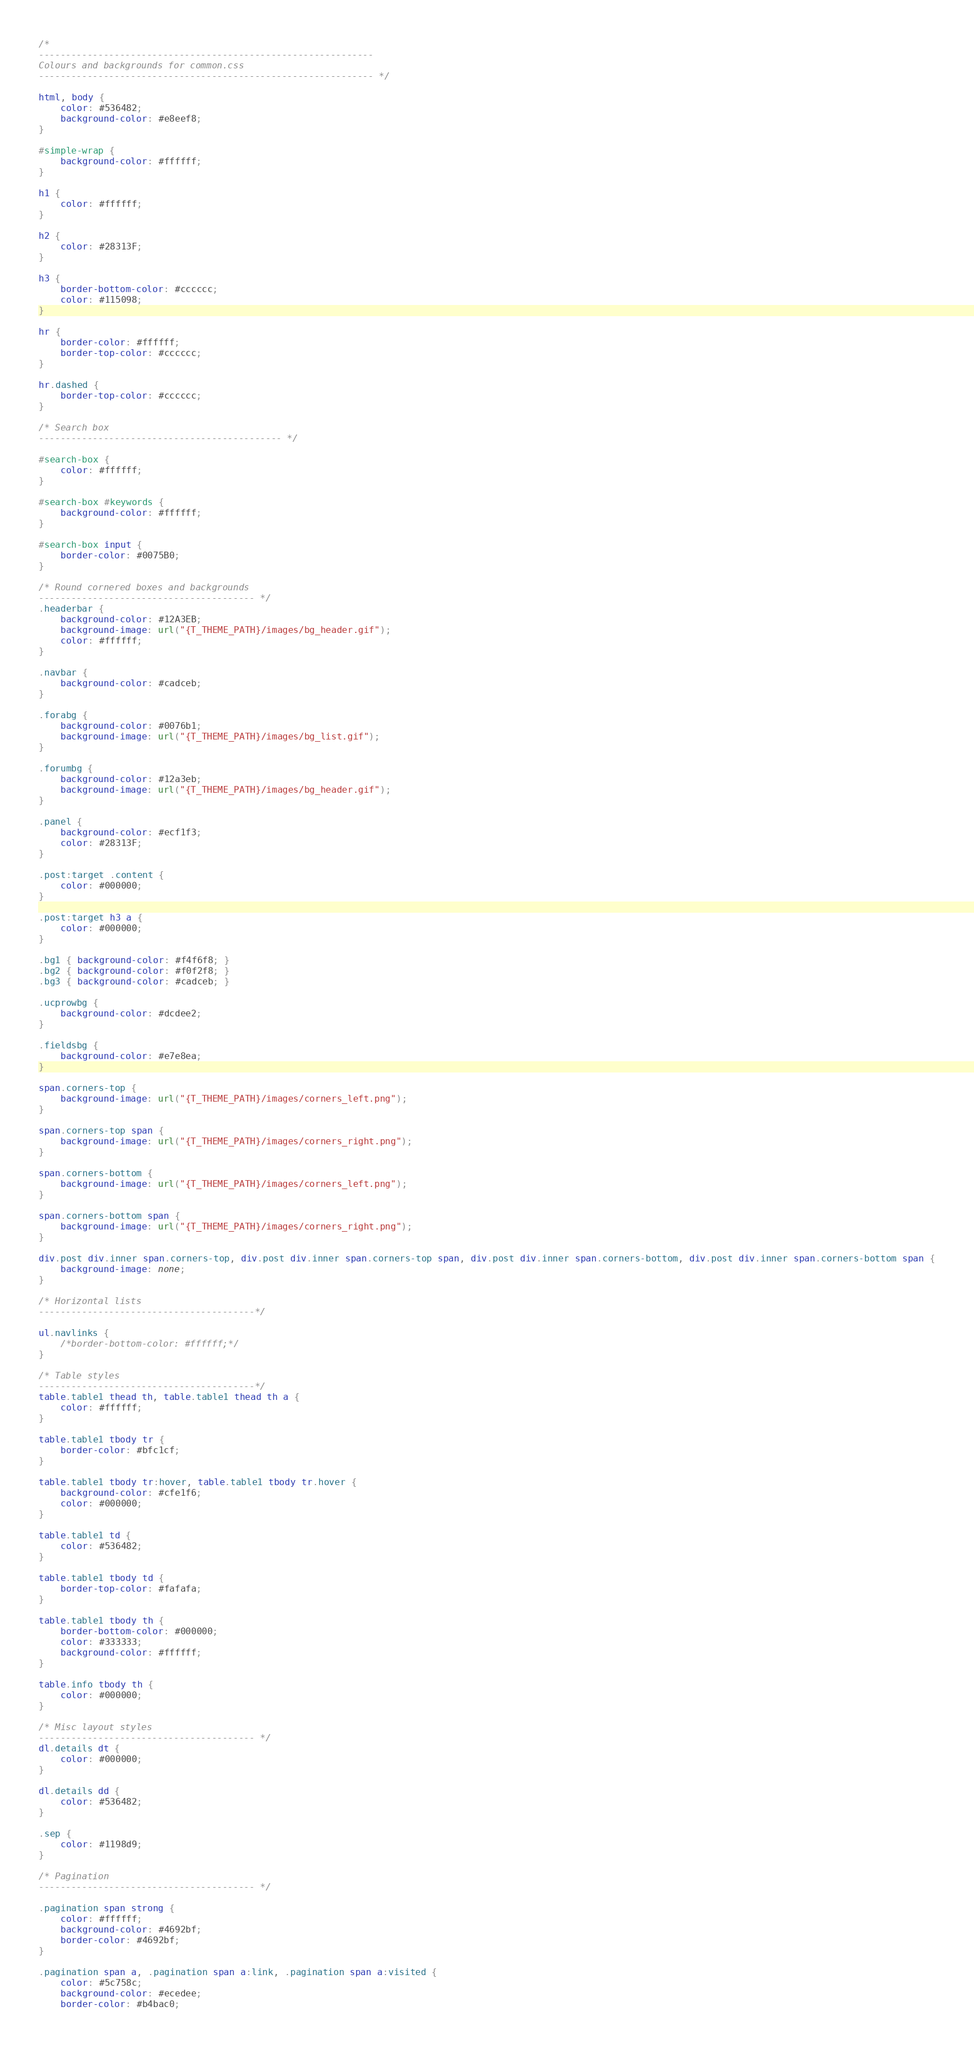<code> <loc_0><loc_0><loc_500><loc_500><_CSS_>/*
--------------------------------------------------------------
Colours and backgrounds for common.css
-------------------------------------------------------------- */

html, body {
	color: #536482;
	background-color: #e8eef8;
}

#simple-wrap {
	background-color: #ffffff;
}

h1 {
	color: #ffffff;
}

h2 {
	color: #28313F;
}

h3 {
	border-bottom-color: #cccccc;
	color: #115098;
}

hr {
	border-color: #ffffff;
	border-top-color: #cccccc;
}

hr.dashed {
	border-top-color: #cccccc;
}

/* Search box
--------------------------------------------- */

#search-box {
	color: #ffffff;
}

#search-box #keywords {
	background-color: #ffffff;
}

#search-box input {
	border-color: #0075B0;
}

/* Round cornered boxes and backgrounds
---------------------------------------- */
.headerbar {
	background-color: #12A3EB;
	background-image: url("{T_THEME_PATH}/images/bg_header.gif");
	color: #ffffff;
}

.navbar {
	background-color: #cadceb;
}

.forabg {
	background-color: #0076b1;
	background-image: url("{T_THEME_PATH}/images/bg_list.gif");
}

.forumbg {
	background-color: #12a3eb;
	background-image: url("{T_THEME_PATH}/images/bg_header.gif");
}

.panel {
	background-color: #ecf1f3;
	color: #28313F;
}

.post:target .content {
	color: #000000;
}

.post:target h3 a {
	color: #000000;
}

.bg1 { background-color: #f4f6f8; }
.bg2 { background-color: #f0f2f8; }
.bg3 { background-color: #cadceb; }

.ucprowbg {
	background-color: #dcdee2;
}

.fieldsbg {
	background-color: #e7e8ea;
}

span.corners-top {
	background-image: url("{T_THEME_PATH}/images/corners_left.png");
}

span.corners-top span {
	background-image: url("{T_THEME_PATH}/images/corners_right.png");
}

span.corners-bottom {
	background-image: url("{T_THEME_PATH}/images/corners_left.png");
}

span.corners-bottom span {
	background-image: url("{T_THEME_PATH}/images/corners_right.png");
}

div.post div.inner span.corners-top, div.post div.inner span.corners-top span, div.post div.inner span.corners-bottom, div.post div.inner span.corners-bottom span {
	background-image: none;
}

/* Horizontal lists
----------------------------------------*/

ul.navlinks {
	/*border-bottom-color: #ffffff;*/
}

/* Table styles
----------------------------------------*/
table.table1 thead th, table.table1 thead th a {
	color: #ffffff;
}

table.table1 tbody tr {
	border-color: #bfc1cf;
}

table.table1 tbody tr:hover, table.table1 tbody tr.hover {
	background-color: #cfe1f6;
	color: #000000;
}

table.table1 td {
	color: #536482;
}

table.table1 tbody td {
	border-top-color: #fafafa;
}

table.table1 tbody th {
	border-bottom-color: #000000;
	color: #333333;
	background-color: #ffffff;
}

table.info tbody th {
	color: #000000;
}

/* Misc layout styles
---------------------------------------- */
dl.details dt {
	color: #000000;
}

dl.details dd {
	color: #536482;
}

.sep {
	color: #1198d9;
}

/* Pagination
---------------------------------------- */

.pagination span strong {
	color: #ffffff;
	background-color: #4692bf;
	border-color: #4692bf;
}

.pagination span a, .pagination span a:link, .pagination span a:visited {
	color: #5c758c;
	background-color: #ecedee;
	border-color: #b4bac0;</code> 